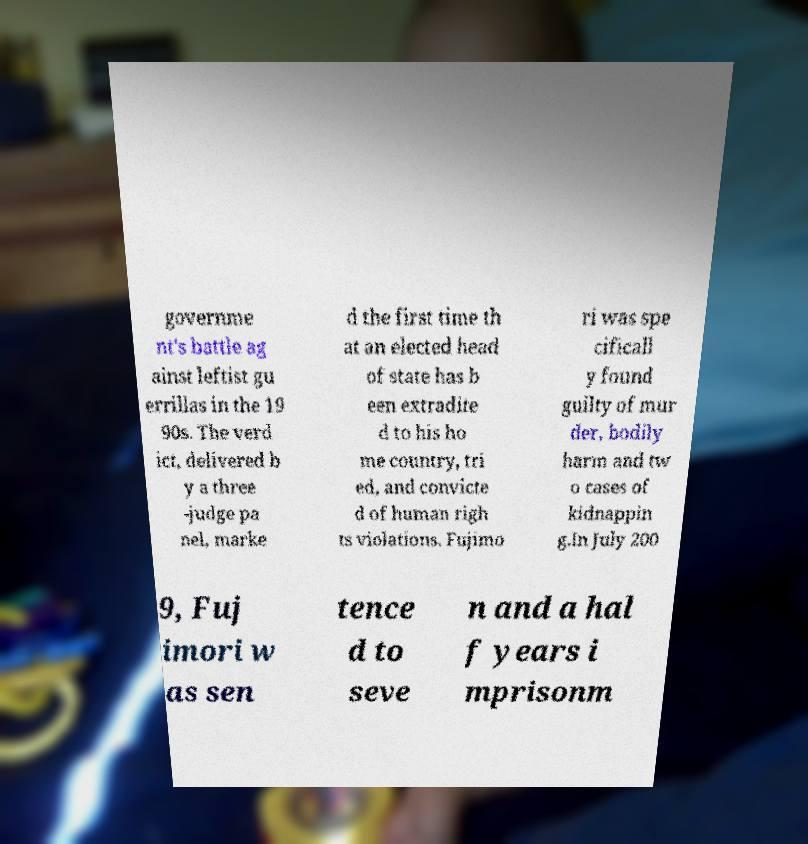What messages or text are displayed in this image? I need them in a readable, typed format. governme nt's battle ag ainst leftist gu errillas in the 19 90s. The verd ict, delivered b y a three -judge pa nel, marke d the first time th at an elected head of state has b een extradite d to his ho me country, tri ed, and convicte d of human righ ts violations. Fujimo ri was spe cificall y found guilty of mur der, bodily harm and tw o cases of kidnappin g.In July 200 9, Fuj imori w as sen tence d to seve n and a hal f years i mprisonm 